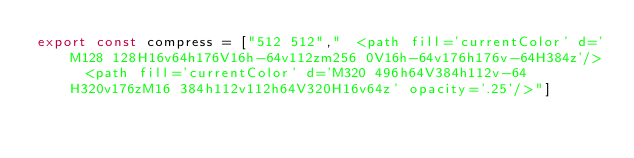<code> <loc_0><loc_0><loc_500><loc_500><_JavaScript_>export const compress = ["512 512","  <path fill='currentColor' d='M128 128H16v64h176V16h-64v112zm256 0V16h-64v176h176v-64H384z'/>  <path fill='currentColor' d='M320 496h64V384h112v-64H320v176zM16 384h112v112h64V320H16v64z' opacity='.25'/>"]</code> 